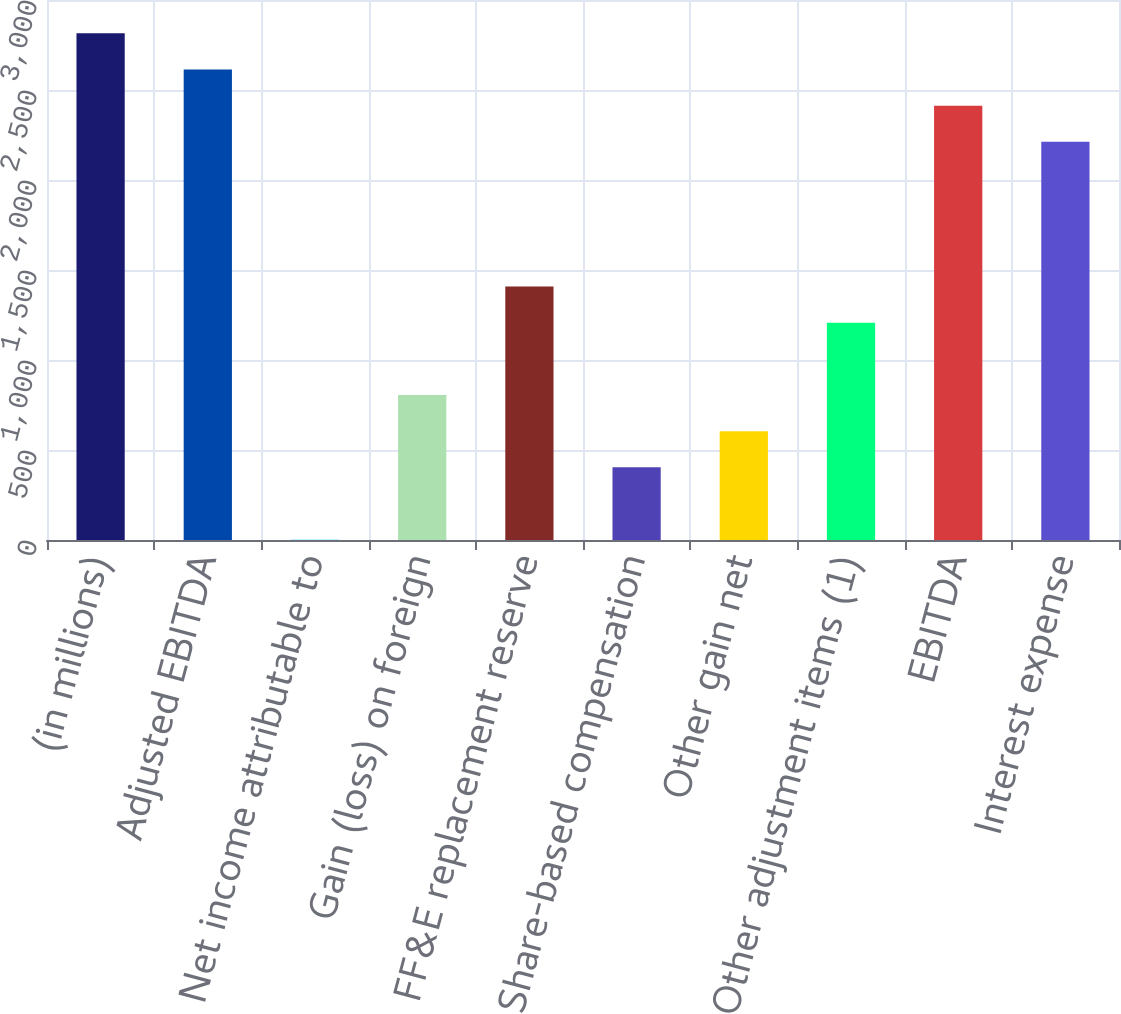<chart> <loc_0><loc_0><loc_500><loc_500><bar_chart><fcel>(in millions)<fcel>Adjusted EBITDA<fcel>Net income attributable to<fcel>Gain (loss) on foreign<fcel>FF&E replacement reserve<fcel>Share-based compensation<fcel>Other gain net<fcel>Other adjustment items (1)<fcel>EBITDA<fcel>Interest expense<nl><fcel>2814.6<fcel>2613.7<fcel>2<fcel>805.6<fcel>1408.3<fcel>403.8<fcel>604.7<fcel>1207.4<fcel>2412.8<fcel>2211.9<nl></chart> 